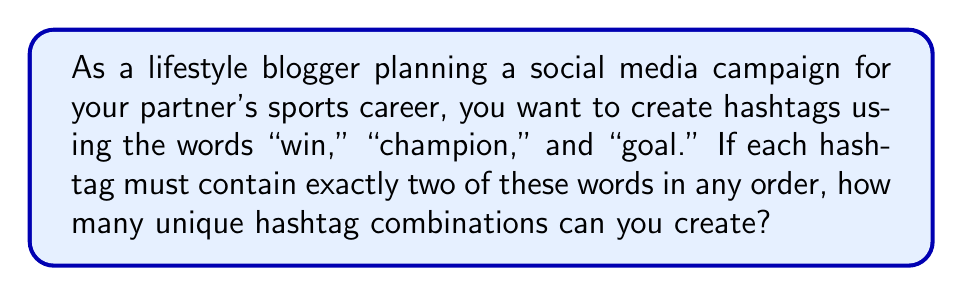Show me your answer to this math problem. Let's approach this step-by-step:

1) We have 3 words to choose from: "win," "champion," and "goal."

2) We need to select 2 words out of these 3 for each hashtag.

3) This is a combination problem, as the order of words within the hashtag matters.

4) We can use the permutation formula:
   $$P(n,r) = \frac{n!}{(n-r)!}$$
   where $n$ is the total number of items to choose from, and $r$ is the number of items being chosen.

5) In this case, $n = 3$ and $r = 2$

6) Plugging these values into the formula:
   $$P(3,2) = \frac{3!}{(3-2)!} = \frac{3!}{1!}$$

7) Simplify:
   $$\frac{3 * 2 * 1}{1} = 6$$

Therefore, you can create 6 unique hashtag combinations.
Answer: 6 hashtag combinations 